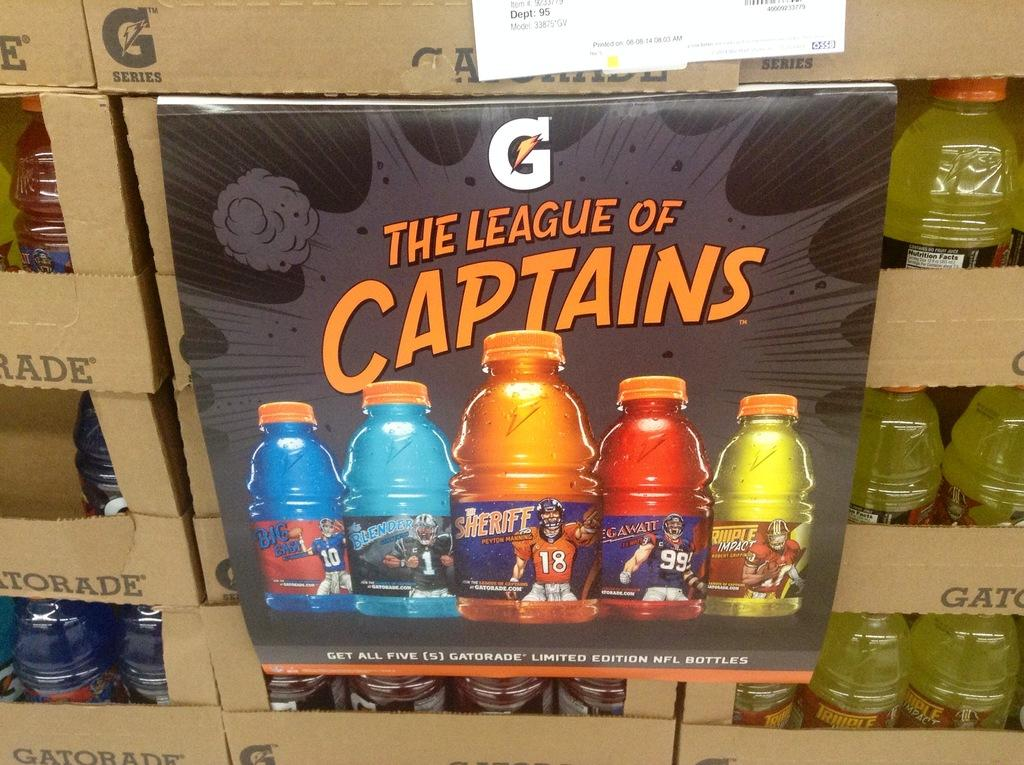<image>
Write a terse but informative summary of the picture. gatorade display with a sign in front showing the league of captains 